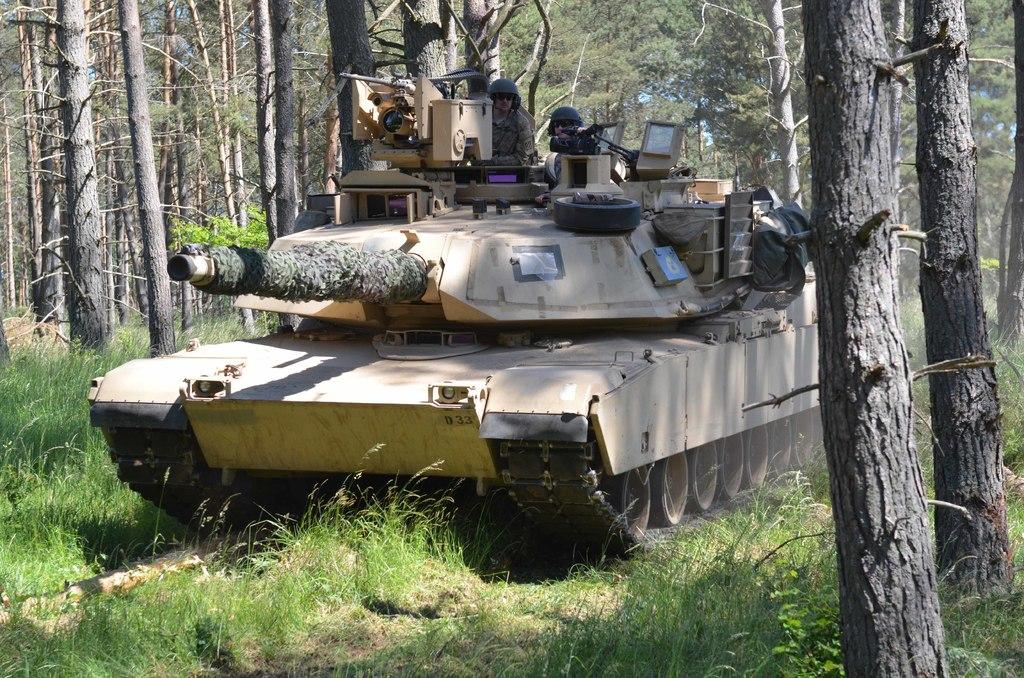What is the main subject of the image? The main subject of the image is a tanker. What else can be seen in the image besides the tanker? There are trees in the image. What type of brass instrument is being played by the tanker in the image? There is no brass instrument or any indication of music being played in the image. The image only features a tanker and trees. 